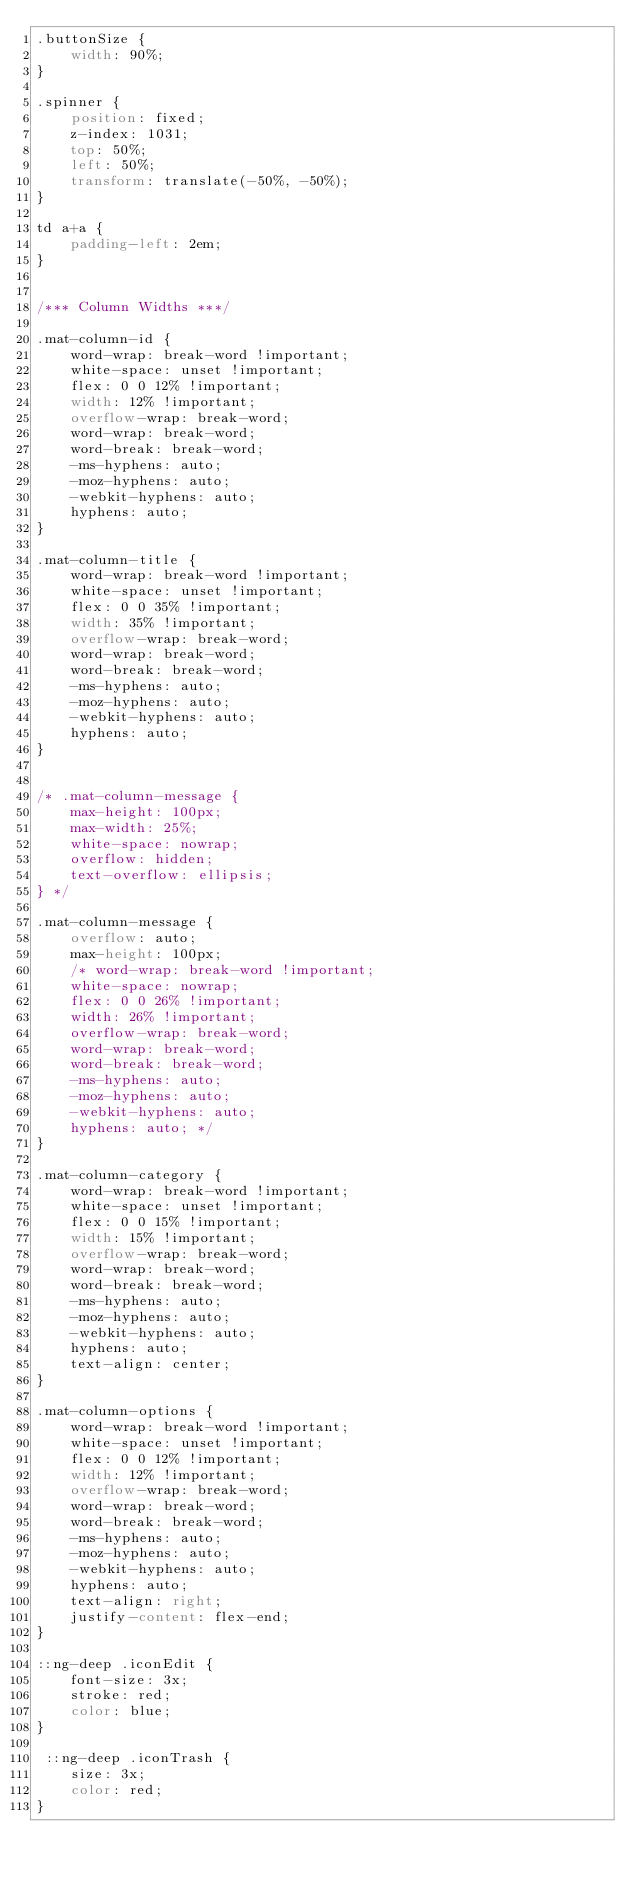<code> <loc_0><loc_0><loc_500><loc_500><_CSS_>.buttonSize {
    width: 90%;
}

.spinner {
    position: fixed;
    z-index: 1031;
    top: 50%;
    left: 50%;
    transform: translate(-50%, -50%);
}

td a+a {
    padding-left: 2em;
}


/*** Column Widths ***/

.mat-column-id {
    word-wrap: break-word !important;
    white-space: unset !important;
    flex: 0 0 12% !important;
    width: 12% !important;
    overflow-wrap: break-word;
    word-wrap: break-word;
    word-break: break-word;
    -ms-hyphens: auto;
    -moz-hyphens: auto;
    -webkit-hyphens: auto;
    hyphens: auto;
}

.mat-column-title {
    word-wrap: break-word !important;
    white-space: unset !important;
    flex: 0 0 35% !important;
    width: 35% !important;
    overflow-wrap: break-word;
    word-wrap: break-word;
    word-break: break-word;
    -ms-hyphens: auto;
    -moz-hyphens: auto;
    -webkit-hyphens: auto;
    hyphens: auto;
}


/* .mat-column-message {
    max-height: 100px;
    max-width: 25%;
    white-space: nowrap;
    overflow: hidden;
    text-overflow: ellipsis;
} */

.mat-column-message {
    overflow: auto;
    max-height: 100px;
    /* word-wrap: break-word !important;
    white-space: nowrap;
    flex: 0 0 26% !important;
    width: 26% !important;
    overflow-wrap: break-word;
    word-wrap: break-word;
    word-break: break-word;
    -ms-hyphens: auto;
    -moz-hyphens: auto;
    -webkit-hyphens: auto;
    hyphens: auto; */
}

.mat-column-category {
    word-wrap: break-word !important;
    white-space: unset !important;
    flex: 0 0 15% !important;
    width: 15% !important;
    overflow-wrap: break-word;
    word-wrap: break-word;
    word-break: break-word;
    -ms-hyphens: auto;
    -moz-hyphens: auto;
    -webkit-hyphens: auto;
    hyphens: auto;
    text-align: center;
}

.mat-column-options {
    word-wrap: break-word !important;
    white-space: unset !important;
    flex: 0 0 12% !important;
    width: 12% !important;
    overflow-wrap: break-word;
    word-wrap: break-word;
    word-break: break-word;
    -ms-hyphens: auto;
    -moz-hyphens: auto;
    -webkit-hyphens: auto;
    hyphens: auto;
    text-align: right;
    justify-content: flex-end;
}

::ng-deep .iconEdit {
    font-size: 3x;
    stroke: red;
    color: blue;
}

 ::ng-deep .iconTrash {
    size: 3x;
    color: red;
}</code> 